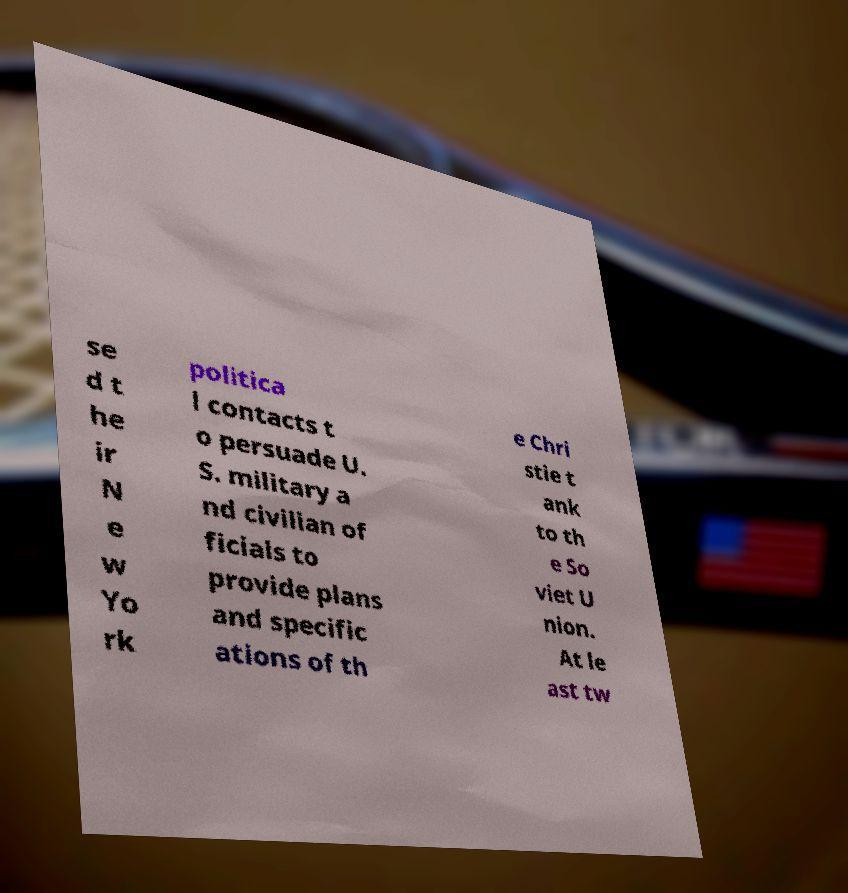I need the written content from this picture converted into text. Can you do that? se d t he ir N e w Yo rk politica l contacts t o persuade U. S. military a nd civilian of ficials to provide plans and specific ations of th e Chri stie t ank to th e So viet U nion. At le ast tw 